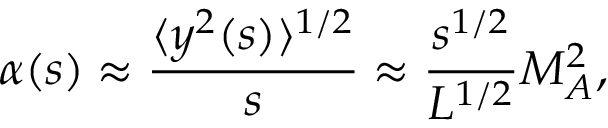Convert formula to latex. <formula><loc_0><loc_0><loc_500><loc_500>\alpha ( s ) \approx \frac { \langle y ^ { 2 } ( s ) \rangle ^ { 1 / 2 } } { s } \approx \frac { s ^ { 1 / 2 } } { L ^ { 1 / 2 } } M _ { A } ^ { 2 } ,</formula> 